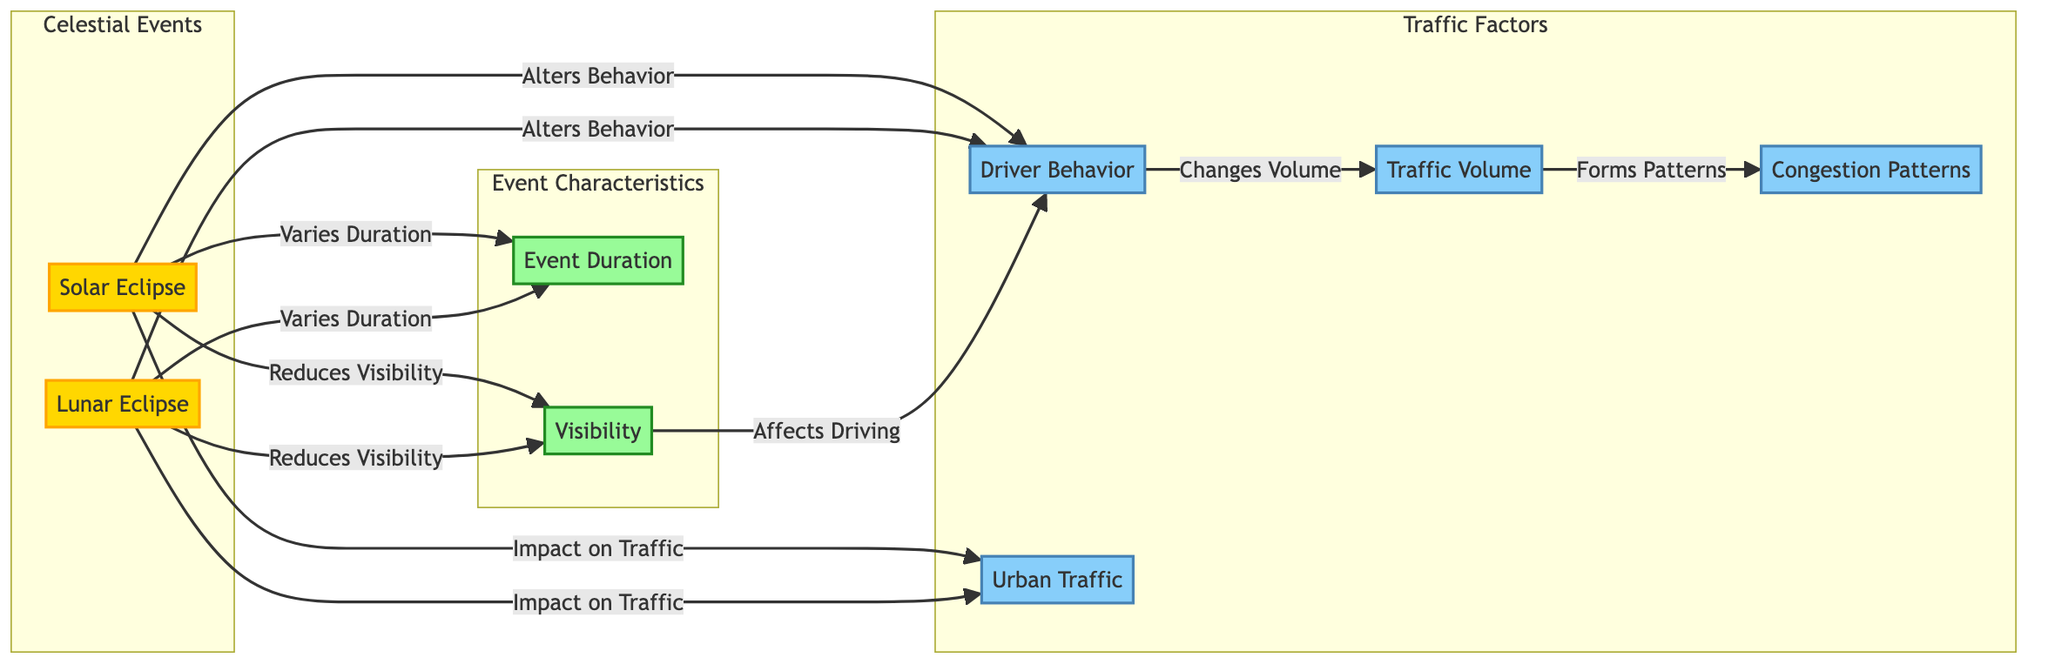What are the two types of celestial events illustrated in the diagram? The diagram clearly identifies two celestial events in the 'Celestial Events' section: Solar Eclipse and Lunar Eclipse.
Answer: Solar Eclipse, Lunar Eclipse How does a solar eclipse impact urban traffic? According to the diagram, a solar eclipse impacts urban traffic by directly connecting to the Urban Traffic node, signifying a relationship between the solar eclipse and urban traffic conditions.
Answer: Impact on Traffic What traffic factor is directly affected by driver behavior? The triangle of relationships shows that Driver Behavior leads to Changes in Volume, indicating a direct connection between driver behavior and traffic volume.
Answer: Changes Volume How many characteristics of celestial events are represented in the diagram? The diagram lists two characteristics under the 'Event Characteristics' subgraph: Event Duration and Visibility, making a total of two characteristics represented.
Answer: Two What effect do both solar and lunar eclipses have on visibility? Both events, solar and lunar eclipses, affect visibility as indicated in the diagram. Specifically, the lines from both eclipse types lead to the Visibility node that states they "Reduce Visibility."
Answer: Reduces Visibility Which traffic factor forms patterns? The diagram illustrates that the Traffic Volume, represented by the Traffic Factors subgraph, leads to Congestion Patterns, indicating that this traffic factor forms patterns.
Answer: Congestion Patterns Which type of eclipse alters driver behavior? The diagram indicates that both Solar Eclipse and Lunar Eclipse alter driver behavior, as shown by the connection from each eclipse type to the Driver Behavior node.
Answer: Both What event characteristic varies with both eclipses? The diagram shows that Event Duration is an event characteristic that varies in the context of both Solar Eclipses and Lunar Eclipses, linking both events to the Duration node.
Answer: Event Duration How many traffic factors are there in total within the diagram? There are four traffic factors shown in the Traffic Factors subgraph: Driver Behavior, Traffic Volume, Congestion Patterns, and Urban Traffic, making a total of four factors present.
Answer: Four 